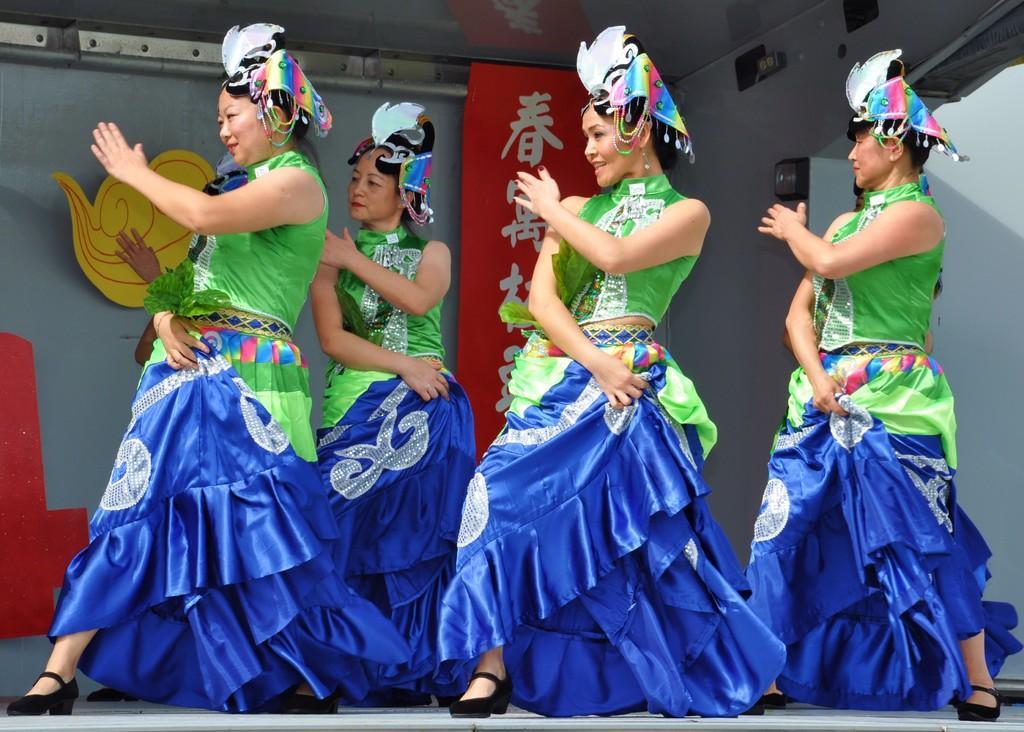Can you describe this image briefly? We can see few women are dancing on the stage. In the background we can see a name board, poles and other objects on the wall. 